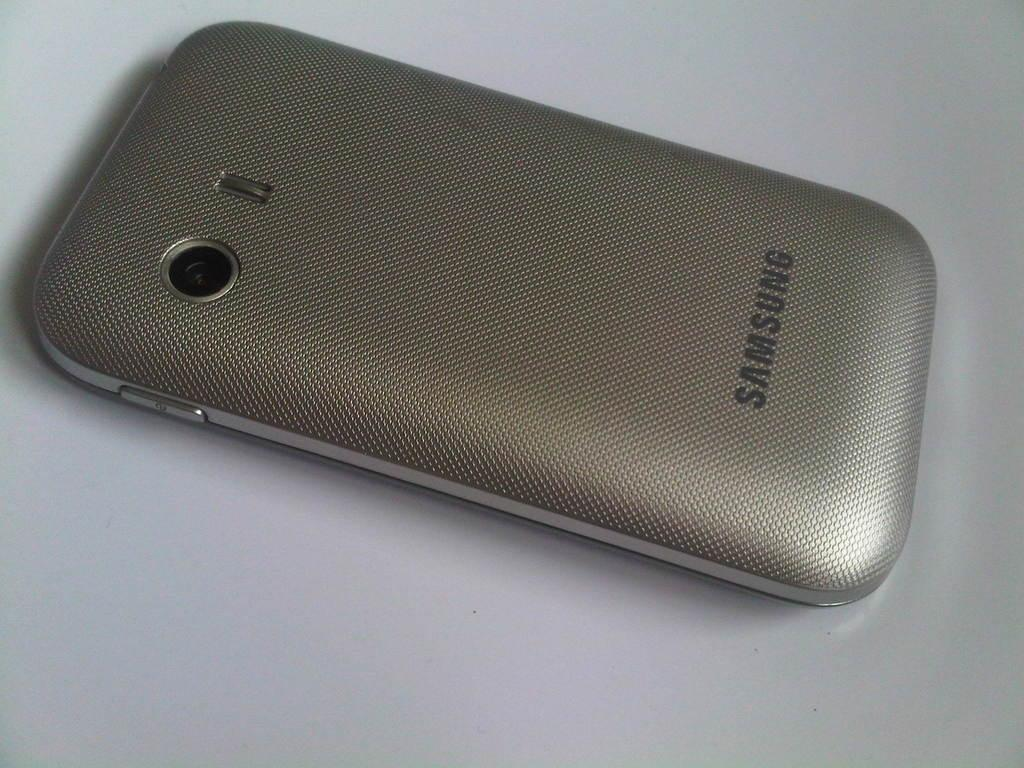<image>
Share a concise interpretation of the image provided. A silver Samsung phone laying on its face. 